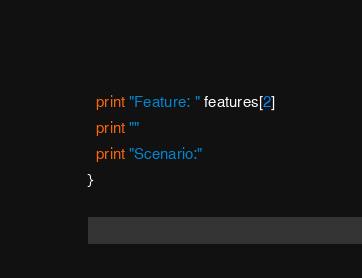Convert code to text. <code><loc_0><loc_0><loc_500><loc_500><_Awk_>  print "Feature: " features[2]
  print ""
  print "Scenario:"
}
</code> 